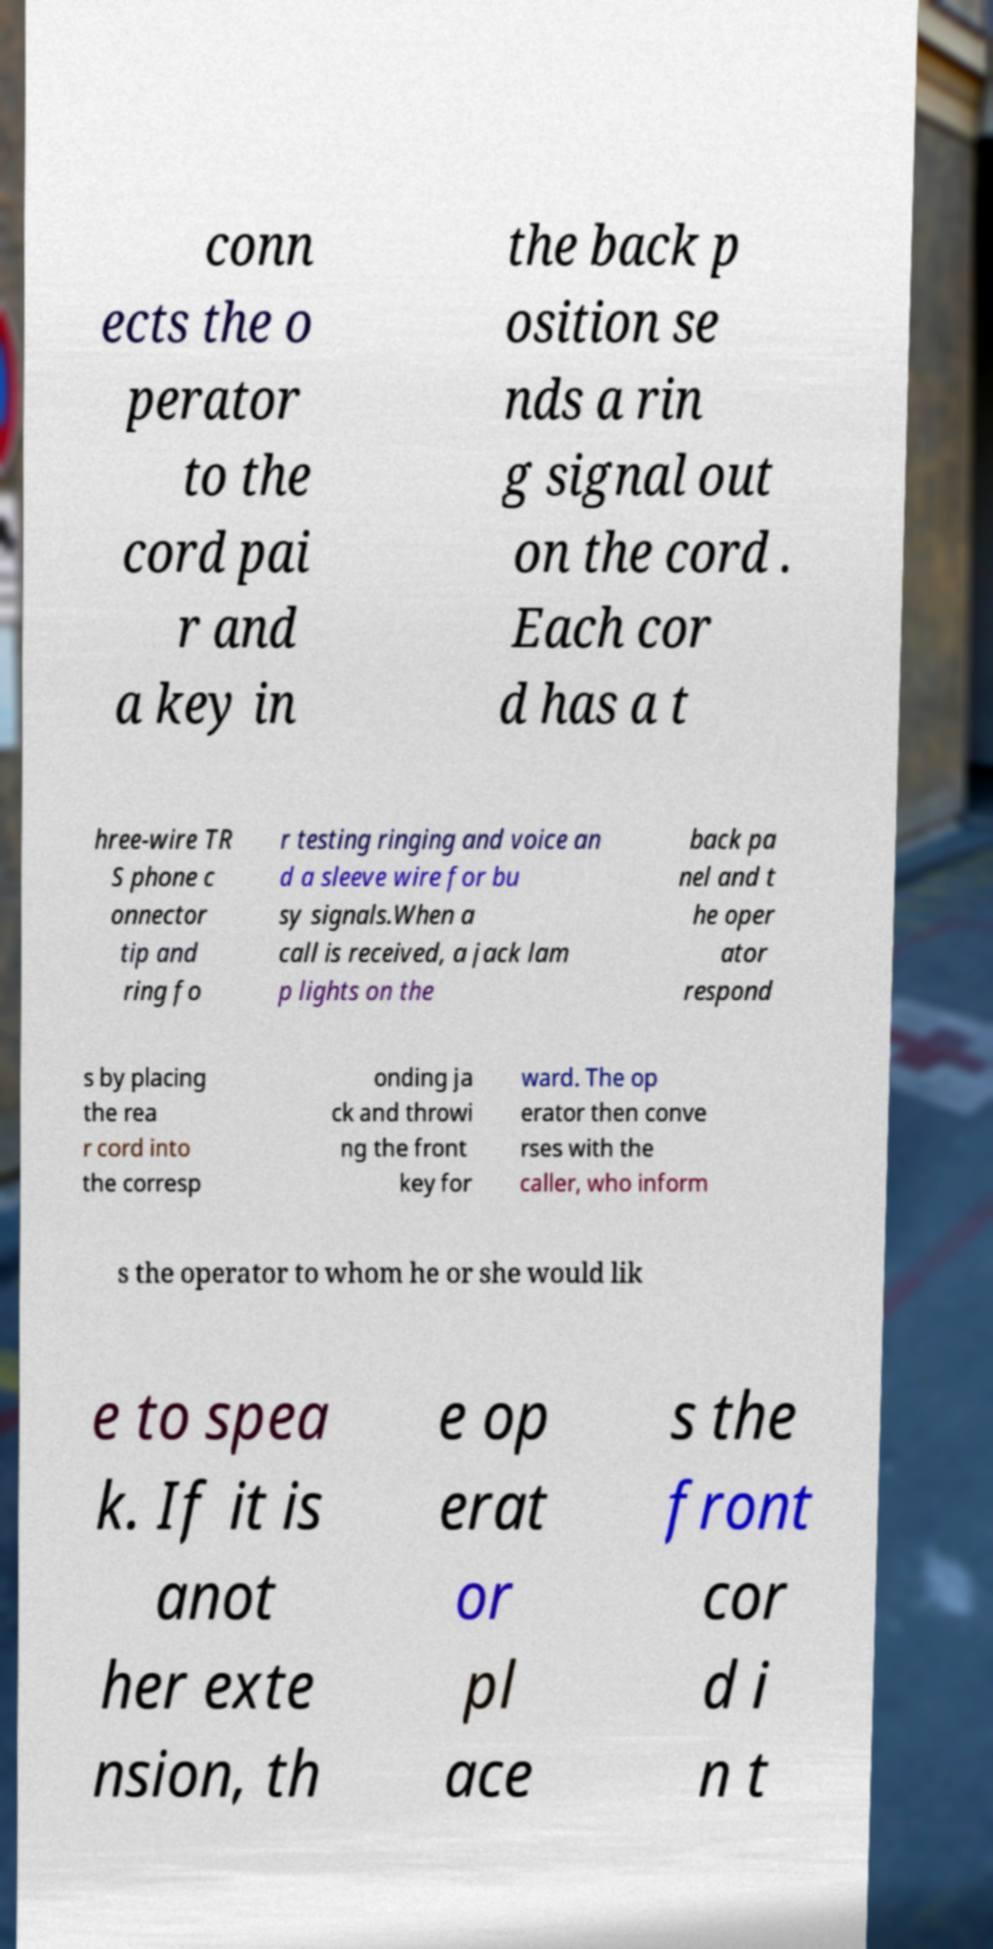Can you read and provide the text displayed in the image?This photo seems to have some interesting text. Can you extract and type it out for me? conn ects the o perator to the cord pai r and a key in the back p osition se nds a rin g signal out on the cord . Each cor d has a t hree-wire TR S phone c onnector tip and ring fo r testing ringing and voice an d a sleeve wire for bu sy signals.When a call is received, a jack lam p lights on the back pa nel and t he oper ator respond s by placing the rea r cord into the corresp onding ja ck and throwi ng the front key for ward. The op erator then conve rses with the caller, who inform s the operator to whom he or she would lik e to spea k. If it is anot her exte nsion, th e op erat or pl ace s the front cor d i n t 